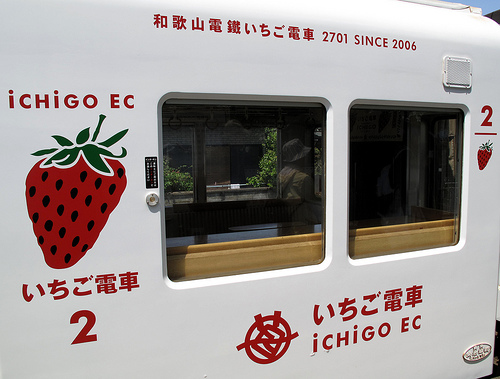<image>
Can you confirm if the strawberry is on the trailer? Yes. Looking at the image, I can see the strawberry is positioned on top of the trailer, with the trailer providing support. 